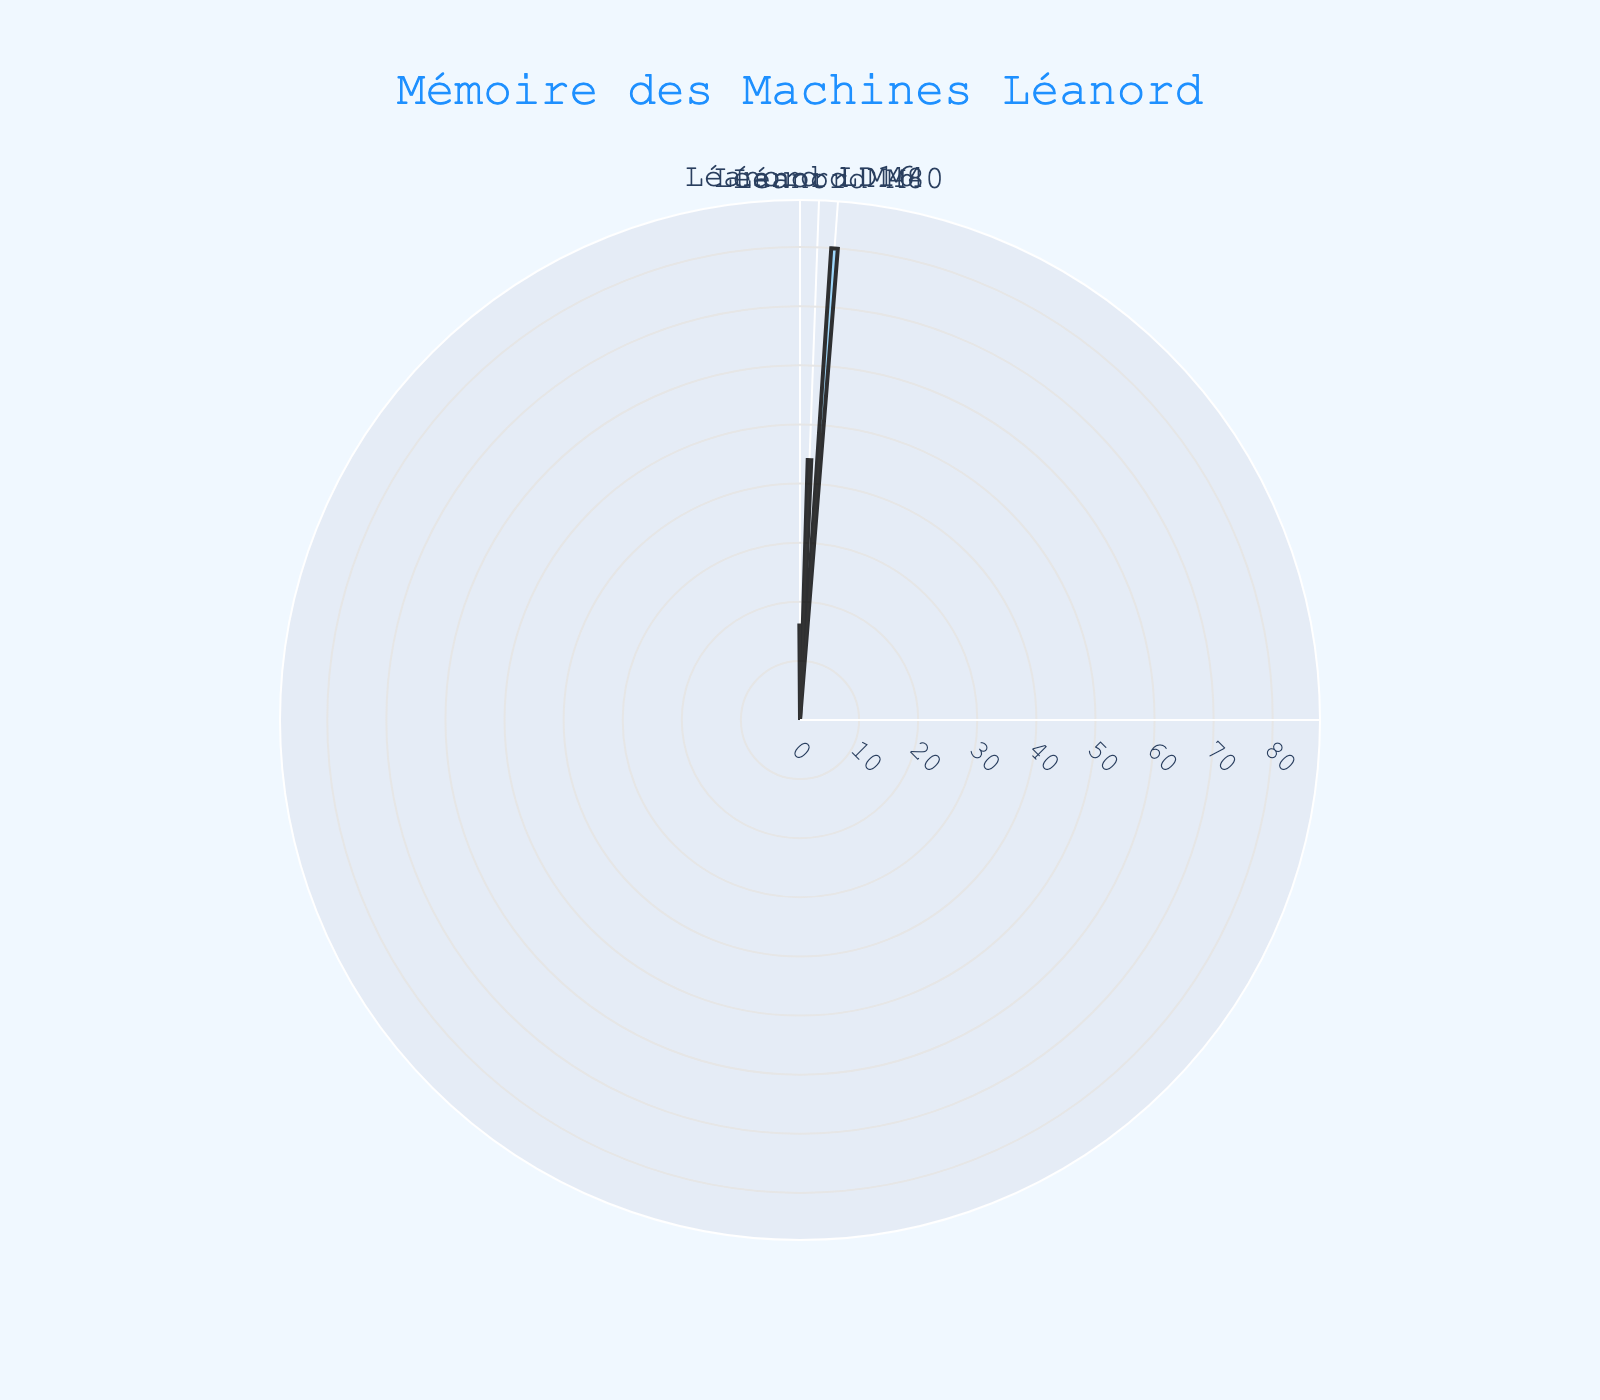What's the title of the figure? The title is located at the top of the figure and represents the main subject of the chart. It reads "Mémoire des Machines Léanord" which translates to "Memory of Léanord Machines."
Answer: "Mémoire des Machines Léanord" Which machine has the largest memory size? By examining the heights of the bars in the rose chart, the Léanord M80 has the largest bar, meaning it has the largest memory size of 80 KB.
Answer: Léanord M80 What is the difference in memory size between the Léanord LD16 and the Léanord M44? The memory size of Léanord LD16 is 16 KB and Léanord M44 is 44 KB. The difference is calculated as 44 - 16 = 28 KB.
Answer: 28 KB List the machines in order of decreasing memory size. By comparing the lengths of the bars, from the longest to the shortest: Léanord M80 (80 KB), Léanord M44 (44 KB), and Léanord LD16 (16 KB).
Answer: Léanord M80, Léanord M44, Léanord LD16 What's the average memory size of the three machines? To find the average, sum the memory sizes of all machines: 16 + 44 + 80 = 140 KB. Then divide by the number of machines, which is 3: 140 / 3 ≈ 46.67 KB.
Answer: 46.67 KB What is the range of memory sizes displayed? The range is found by subtracting the smallest memory size (16 KB) from the largest memory size (80 KB): 80 - 16 = 64 KB.
Answer: 64 KB Which machine's bar uses the lightest blue color? By referring to the color scheme, the Léanord M80's bar is represented in a light blue color in the figure.
Answer: Léanord M80 Calculate the percentage of total memory size represented by the Léanord M44. First, sum up the total memory sizes: 16 + 44 + 80 = 140 KB. Then, the percentage for Léanord M44 is (44 / 140) * 100 ≈ 31.43%.
Answer: 31.43% How many bars are there in the rose chart? Each bar in the rose chart represents a machine, and there are three machines listed: Léanord LD16, Léanord M44, and Léanord M80. Thus, there are three bars.
Answer: 3 Which machine's memory size is closest to the average memory size of 46.67 KB? Comparing the memory sizes, Léanord M44 with 44 KB is the closest to the average memory size of 46.67 KB.
Answer: Léanord M44 